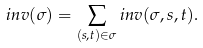<formula> <loc_0><loc_0><loc_500><loc_500>i n v ( \sigma ) = \sum _ { ( s , t ) \in \sigma } i n v ( \sigma , s , t ) .</formula> 